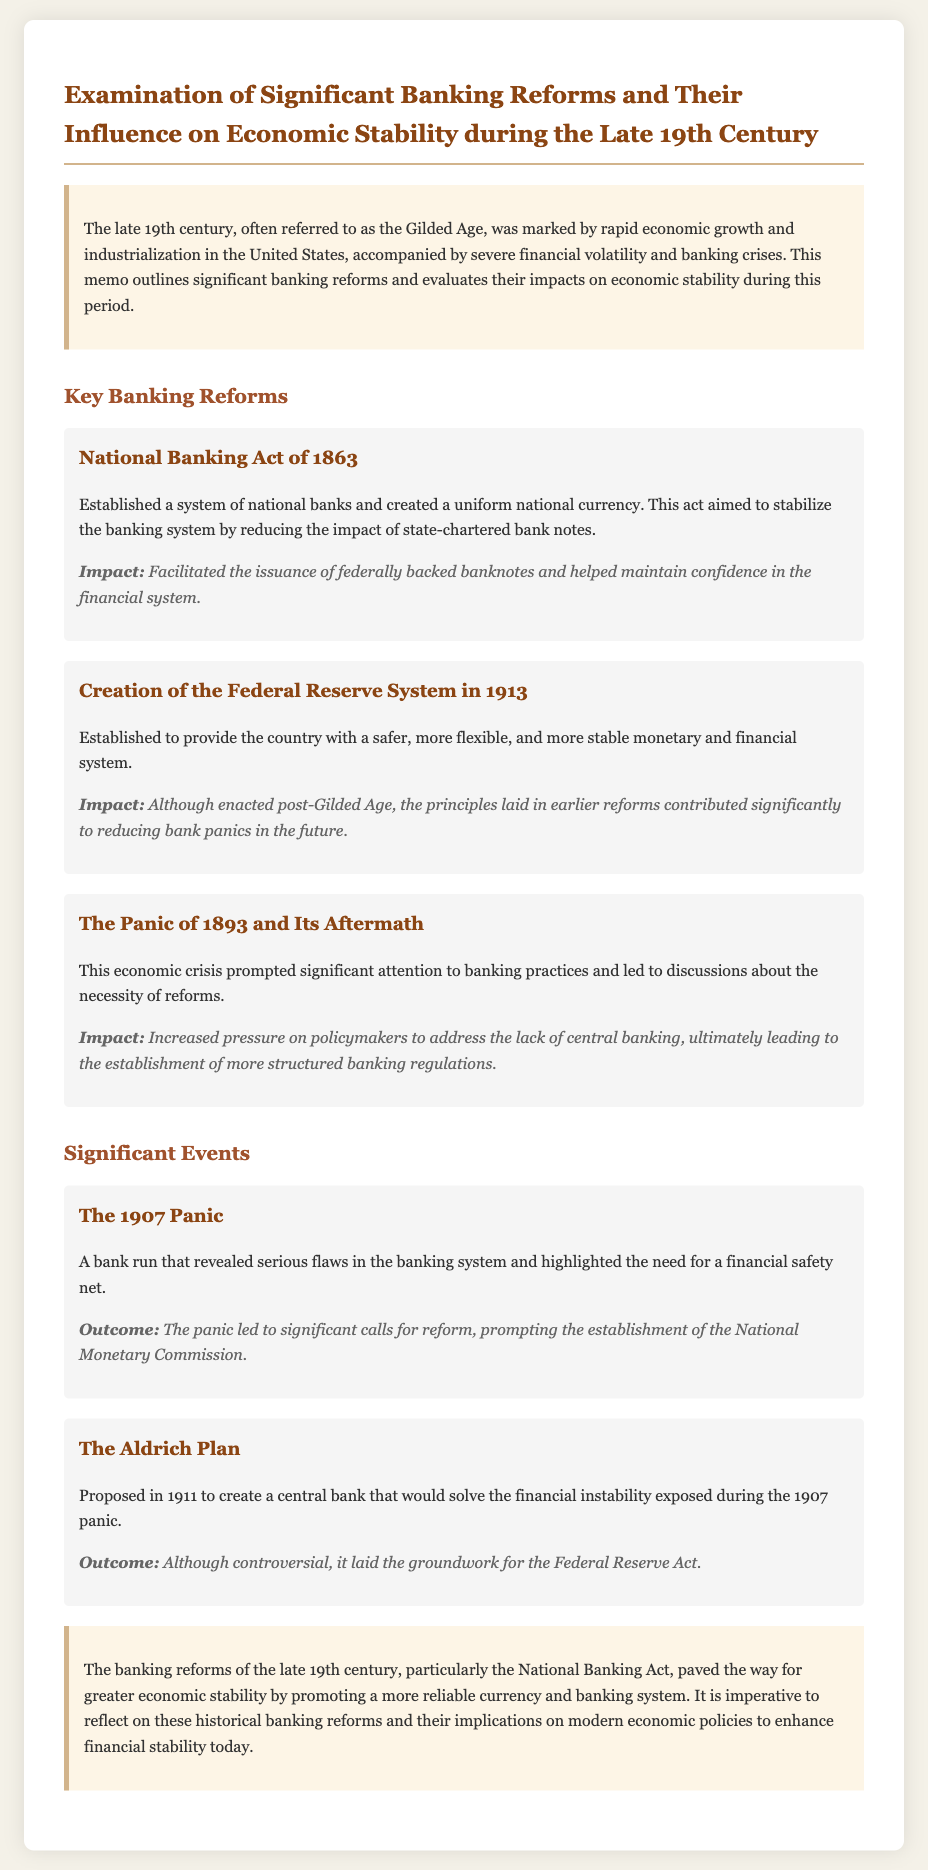What was the year of the National Banking Act? The National Banking Act was established in 1863.
Answer: 1863 What economic crisis prompted significant attention to banking practices? The Panic of 1893 caused scrutiny towards banking practices.
Answer: Panic of 1893 What was the outcome of the 1907 Panic? The 1907 Panic led to calls for reform and the establishment of the National Monetary Commission.
Answer: National Monetary Commission What did the Aldrich Plan propose? The Aldrich Plan proposed creating a central bank to solve financial instability.
Answer: Central bank Which act established a uniform national currency? The National Banking Act of 1863 established a uniform national currency.
Answer: National Banking Act of 1863 What was the primary aim of the Federal Reserve System? The aim of the Federal Reserve System was to provide a safer, more flexible, and stable financial system.
Answer: Safer, more flexible, and stable financial system What significant event highlighted the flaws in the banking system? The 1907 Panic revealed serious flaws in the banking system.
Answer: 1907 Panic What major banking reform took place after the Gilded Age? The creation of the Federal Reserve System occurred post-Gilded Age.
Answer: Federal Reserve System 